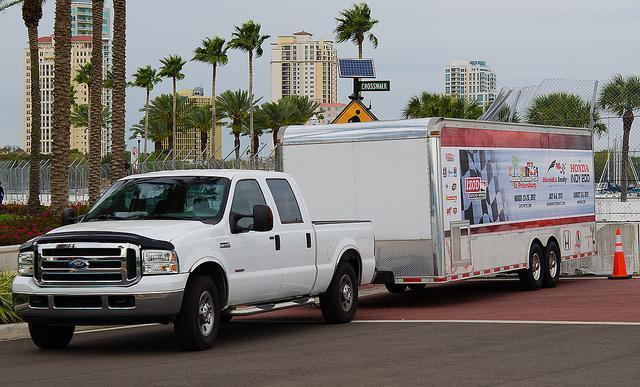How many orange cones are there?
Give a very brief answer. 1. 